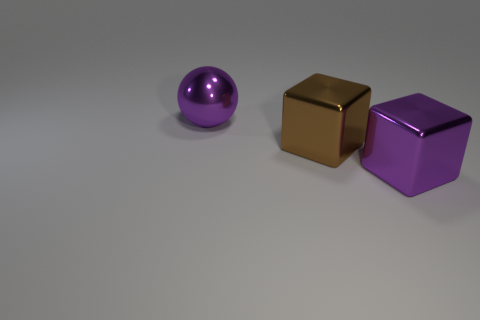What is the shape of the brown shiny thing that is the same size as the ball?
Your answer should be very brief. Cube. What number of metal objects are behind the purple metallic block and on the right side of the purple sphere?
Give a very brief answer. 1. Are there fewer large brown cubes that are behind the large brown block than big purple metallic objects?
Provide a succinct answer. Yes. Are there any purple metal balls that have the same size as the purple cube?
Your response must be concise. Yes. What is the color of the large cube that is the same material as the big brown thing?
Provide a succinct answer. Purple. What number of purple things are to the right of the metal object on the left side of the brown thing?
Give a very brief answer. 1. The thing that is both right of the metal ball and behind the purple metallic cube is made of what material?
Provide a succinct answer. Metal. Do the purple shiny thing that is in front of the ball and the brown object have the same shape?
Your answer should be compact. Yes. Is the number of purple objects less than the number of large brown metal blocks?
Make the answer very short. No. How many big objects are the same color as the sphere?
Your response must be concise. 1. 